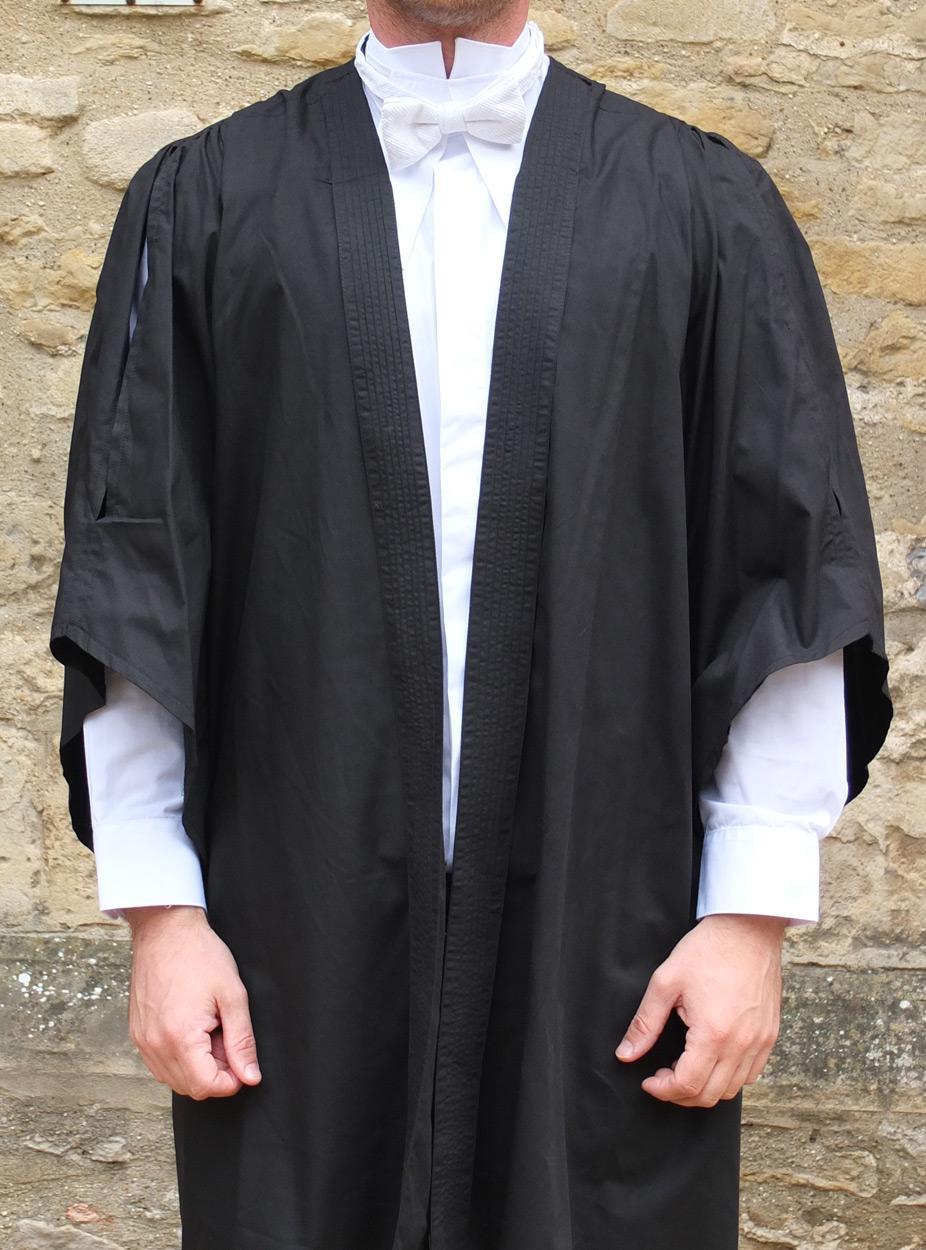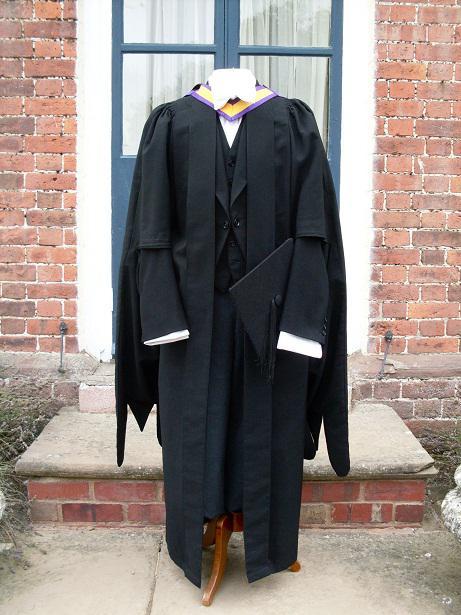The first image is the image on the left, the second image is the image on the right. Analyze the images presented: Is the assertion "Each image shows a real person modeling graduation attire, with one image showing a front view and the other image showing a rear view." valid? Answer yes or no. No. 